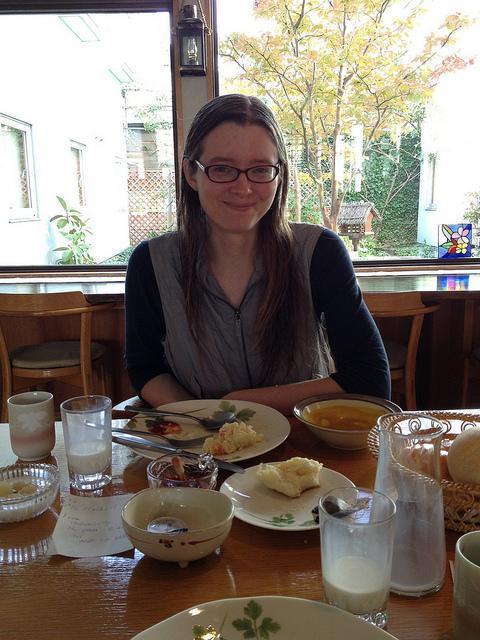How many cups are on the girls right?
Give a very brief answer. 2. How many chairs can be seen?
Give a very brief answer. 2. How many bowls are visible?
Give a very brief answer. 5. How many cups are in the picture?
Give a very brief answer. 6. How many train cars are under the poles?
Give a very brief answer. 0. 